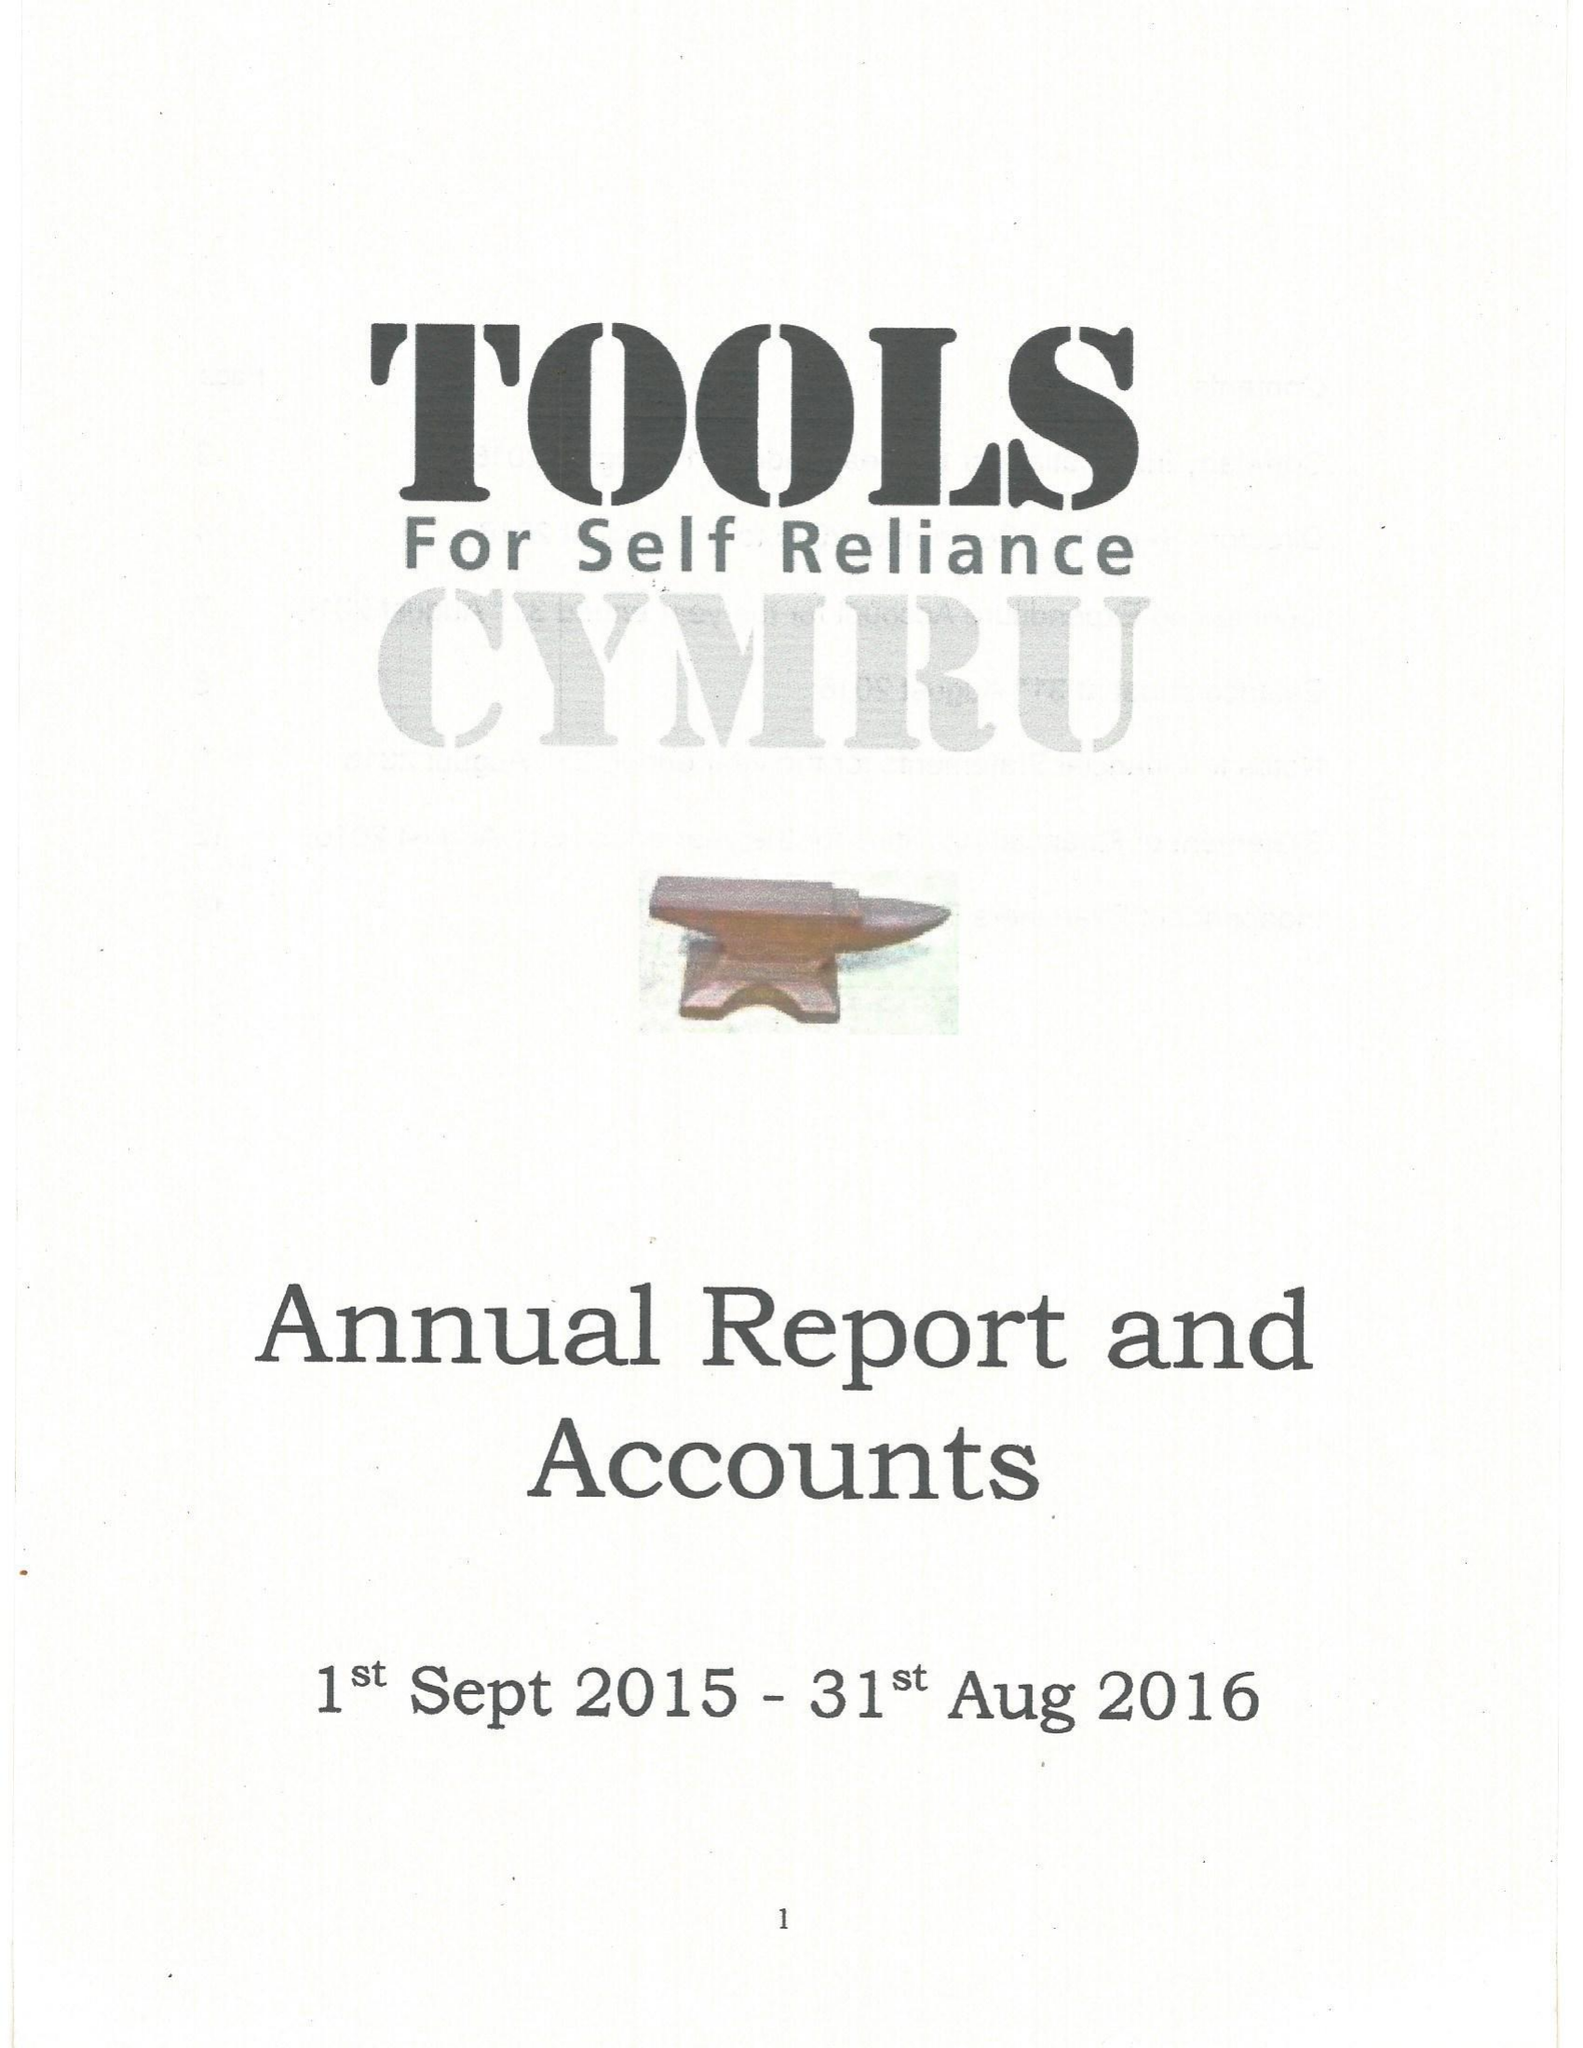What is the value for the spending_annually_in_british_pounds?
Answer the question using a single word or phrase. 156278.00 